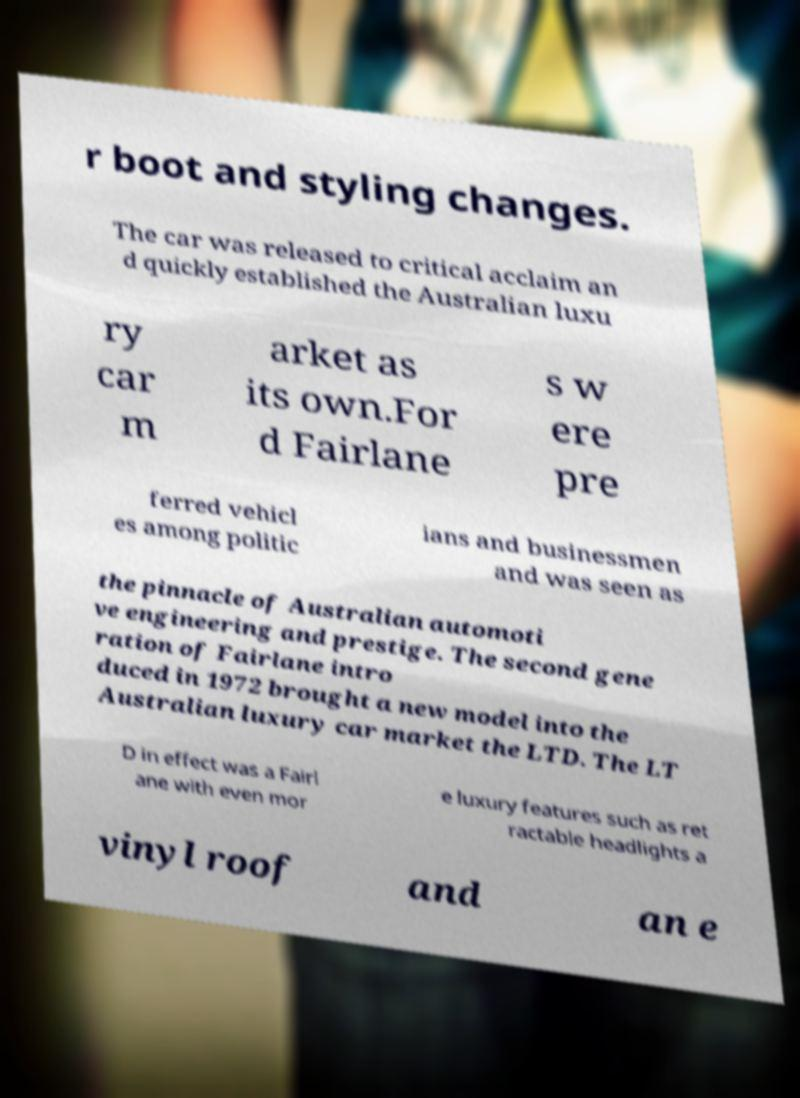I need the written content from this picture converted into text. Can you do that? r boot and styling changes. The car was released to critical acclaim an d quickly established the Australian luxu ry car m arket as its own.For d Fairlane s w ere pre ferred vehicl es among politic ians and businessmen and was seen as the pinnacle of Australian automoti ve engineering and prestige. The second gene ration of Fairlane intro duced in 1972 brought a new model into the Australian luxury car market the LTD. The LT D in effect was a Fairl ane with even mor e luxury features such as ret ractable headlights a vinyl roof and an e 